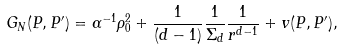Convert formula to latex. <formula><loc_0><loc_0><loc_500><loc_500>G _ { N } ( P , P ^ { \prime } ) = \alpha ^ { - 1 } \rho _ { 0 } ^ { 2 } + \frac { 1 } { ( d - 1 ) } \frac { 1 } { \Sigma _ { d } } \frac { 1 } { r ^ { d - 1 } } + v ( P , P ^ { \prime } ) ,</formula> 